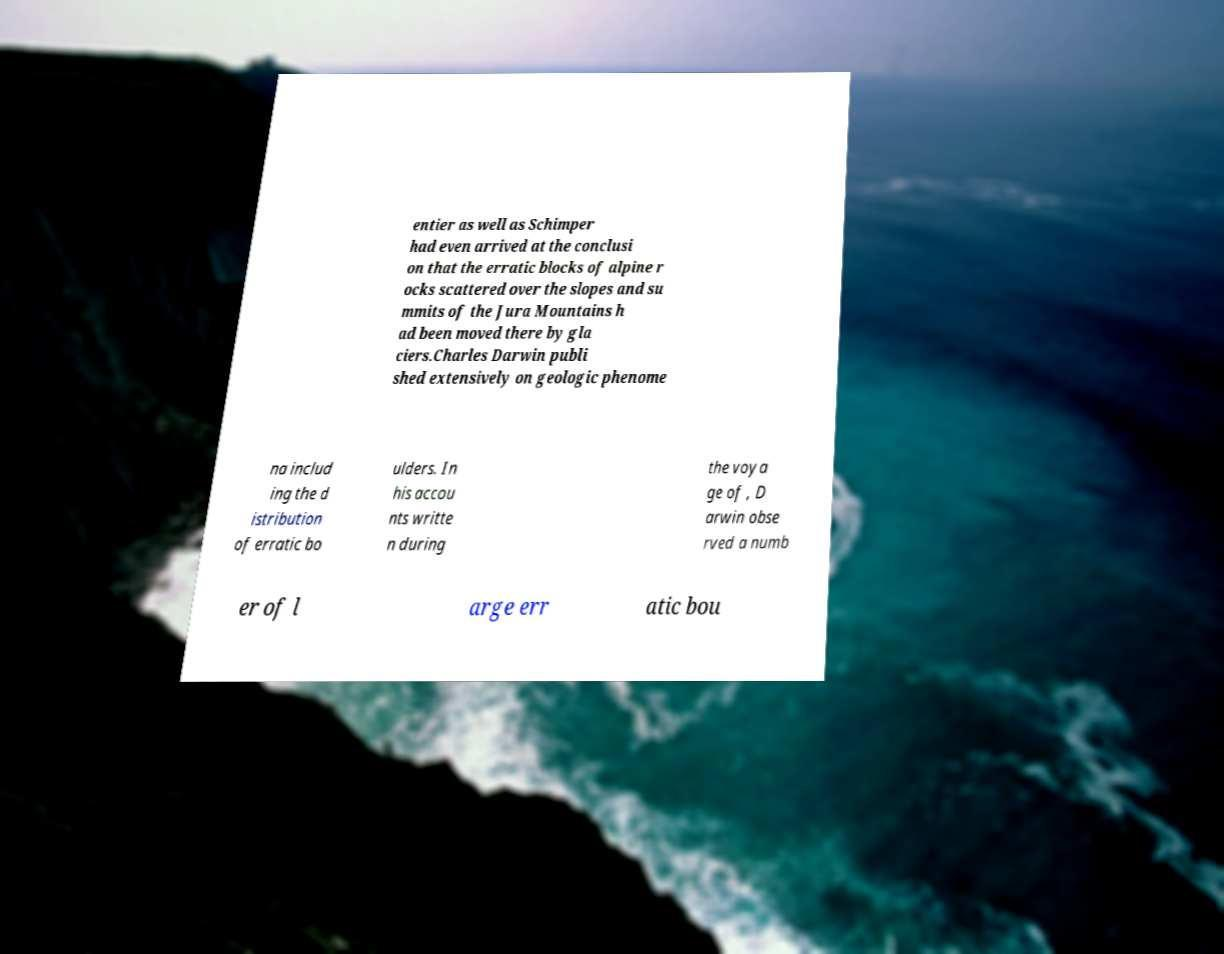I need the written content from this picture converted into text. Can you do that? entier as well as Schimper had even arrived at the conclusi on that the erratic blocks of alpine r ocks scattered over the slopes and su mmits of the Jura Mountains h ad been moved there by gla ciers.Charles Darwin publi shed extensively on geologic phenome na includ ing the d istribution of erratic bo ulders. In his accou nts writte n during the voya ge of , D arwin obse rved a numb er of l arge err atic bou 